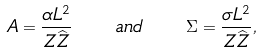Convert formula to latex. <formula><loc_0><loc_0><loc_500><loc_500>A = \frac { \alpha L ^ { 2 } } { Z \widehat { Z } } \quad a n d \quad \Sigma = \frac { \sigma L ^ { 2 } } { Z \widehat { Z } } ,</formula> 